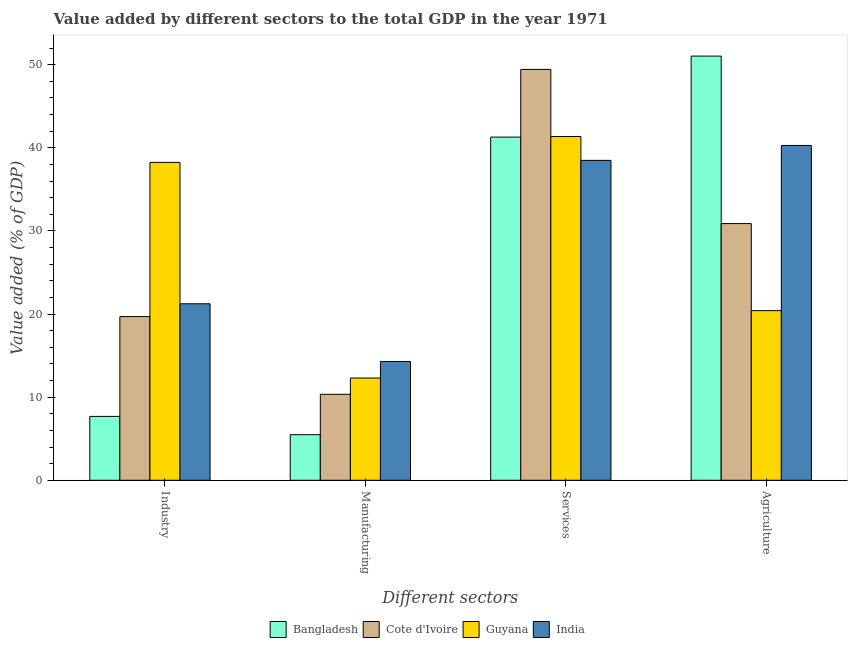How many different coloured bars are there?
Your answer should be very brief. 4. How many groups of bars are there?
Offer a very short reply. 4. Are the number of bars per tick equal to the number of legend labels?
Offer a very short reply. Yes. Are the number of bars on each tick of the X-axis equal?
Your answer should be compact. Yes. How many bars are there on the 1st tick from the left?
Make the answer very short. 4. What is the label of the 3rd group of bars from the left?
Your answer should be compact. Services. What is the value added by agricultural sector in Guyana?
Offer a very short reply. 20.41. Across all countries, what is the maximum value added by agricultural sector?
Ensure brevity in your answer.  51.03. Across all countries, what is the minimum value added by industrial sector?
Your answer should be very brief. 7.68. In which country was the value added by industrial sector minimum?
Your answer should be compact. Bangladesh. What is the total value added by services sector in the graph?
Provide a succinct answer. 170.55. What is the difference between the value added by manufacturing sector in Cote d'Ivoire and that in Guyana?
Offer a very short reply. -1.96. What is the difference between the value added by services sector in Cote d'Ivoire and the value added by agricultural sector in Bangladesh?
Provide a short and direct response. -1.6. What is the average value added by agricultural sector per country?
Give a very brief answer. 35.65. What is the difference between the value added by services sector and value added by industrial sector in Guyana?
Your answer should be compact. 3.11. In how many countries, is the value added by manufacturing sector greater than 36 %?
Keep it short and to the point. 0. What is the ratio of the value added by manufacturing sector in Cote d'Ivoire to that in Bangladesh?
Ensure brevity in your answer.  1.88. Is the value added by agricultural sector in Guyana less than that in India?
Your answer should be compact. Yes. Is the difference between the value added by manufacturing sector in Bangladesh and Cote d'Ivoire greater than the difference between the value added by agricultural sector in Bangladesh and Cote d'Ivoire?
Give a very brief answer. No. What is the difference between the highest and the second highest value added by agricultural sector?
Offer a very short reply. 10.75. What is the difference between the highest and the lowest value added by industrial sector?
Your response must be concise. 30.56. Is the sum of the value added by services sector in Cote d'Ivoire and Guyana greater than the maximum value added by agricultural sector across all countries?
Give a very brief answer. Yes. Is it the case that in every country, the sum of the value added by services sector and value added by manufacturing sector is greater than the sum of value added by agricultural sector and value added by industrial sector?
Keep it short and to the point. No. What does the 3rd bar from the left in Manufacturing represents?
Provide a short and direct response. Guyana. What does the 2nd bar from the right in Services represents?
Ensure brevity in your answer.  Guyana. Are all the bars in the graph horizontal?
Your response must be concise. No. How many countries are there in the graph?
Your answer should be very brief. 4. What is the difference between two consecutive major ticks on the Y-axis?
Your answer should be very brief. 10. Does the graph contain grids?
Your answer should be very brief. No. Where does the legend appear in the graph?
Offer a terse response. Bottom center. How are the legend labels stacked?
Ensure brevity in your answer.  Horizontal. What is the title of the graph?
Your answer should be very brief. Value added by different sectors to the total GDP in the year 1971. What is the label or title of the X-axis?
Your response must be concise. Different sectors. What is the label or title of the Y-axis?
Your response must be concise. Value added (% of GDP). What is the Value added (% of GDP) of Bangladesh in Industry?
Your answer should be compact. 7.68. What is the Value added (% of GDP) in Cote d'Ivoire in Industry?
Your answer should be compact. 19.69. What is the Value added (% of GDP) in Guyana in Industry?
Offer a very short reply. 38.24. What is the Value added (% of GDP) in India in Industry?
Provide a short and direct response. 21.23. What is the Value added (% of GDP) in Bangladesh in Manufacturing?
Your answer should be compact. 5.49. What is the Value added (% of GDP) of Cote d'Ivoire in Manufacturing?
Make the answer very short. 10.34. What is the Value added (% of GDP) of Guyana in Manufacturing?
Offer a terse response. 12.3. What is the Value added (% of GDP) of India in Manufacturing?
Your response must be concise. 14.29. What is the Value added (% of GDP) in Bangladesh in Services?
Your response must be concise. 41.28. What is the Value added (% of GDP) of Cote d'Ivoire in Services?
Provide a succinct answer. 49.43. What is the Value added (% of GDP) in Guyana in Services?
Make the answer very short. 41.35. What is the Value added (% of GDP) in India in Services?
Ensure brevity in your answer.  38.49. What is the Value added (% of GDP) of Bangladesh in Agriculture?
Offer a terse response. 51.03. What is the Value added (% of GDP) in Cote d'Ivoire in Agriculture?
Provide a succinct answer. 30.88. What is the Value added (% of GDP) of Guyana in Agriculture?
Provide a short and direct response. 20.41. What is the Value added (% of GDP) of India in Agriculture?
Ensure brevity in your answer.  40.28. Across all Different sectors, what is the maximum Value added (% of GDP) of Bangladesh?
Provide a succinct answer. 51.03. Across all Different sectors, what is the maximum Value added (% of GDP) in Cote d'Ivoire?
Keep it short and to the point. 49.43. Across all Different sectors, what is the maximum Value added (% of GDP) in Guyana?
Your answer should be compact. 41.35. Across all Different sectors, what is the maximum Value added (% of GDP) in India?
Make the answer very short. 40.28. Across all Different sectors, what is the minimum Value added (% of GDP) in Bangladesh?
Keep it short and to the point. 5.49. Across all Different sectors, what is the minimum Value added (% of GDP) of Cote d'Ivoire?
Give a very brief answer. 10.34. Across all Different sectors, what is the minimum Value added (% of GDP) of Guyana?
Offer a terse response. 12.3. Across all Different sectors, what is the minimum Value added (% of GDP) of India?
Your answer should be compact. 14.29. What is the total Value added (% of GDP) in Bangladesh in the graph?
Your response must be concise. 105.49. What is the total Value added (% of GDP) of Cote d'Ivoire in the graph?
Make the answer very short. 110.34. What is the total Value added (% of GDP) of Guyana in the graph?
Ensure brevity in your answer.  112.3. What is the total Value added (% of GDP) in India in the graph?
Your answer should be compact. 114.29. What is the difference between the Value added (% of GDP) in Bangladesh in Industry and that in Manufacturing?
Your answer should be compact. 2.2. What is the difference between the Value added (% of GDP) in Cote d'Ivoire in Industry and that in Manufacturing?
Offer a very short reply. 9.35. What is the difference between the Value added (% of GDP) of Guyana in Industry and that in Manufacturing?
Provide a succinct answer. 25.94. What is the difference between the Value added (% of GDP) of India in Industry and that in Manufacturing?
Keep it short and to the point. 6.94. What is the difference between the Value added (% of GDP) in Bangladesh in Industry and that in Services?
Provide a succinct answer. -33.6. What is the difference between the Value added (% of GDP) of Cote d'Ivoire in Industry and that in Services?
Your answer should be compact. -29.73. What is the difference between the Value added (% of GDP) in Guyana in Industry and that in Services?
Offer a very short reply. -3.11. What is the difference between the Value added (% of GDP) of India in Industry and that in Services?
Provide a succinct answer. -17.25. What is the difference between the Value added (% of GDP) in Bangladesh in Industry and that in Agriculture?
Offer a terse response. -43.35. What is the difference between the Value added (% of GDP) in Cote d'Ivoire in Industry and that in Agriculture?
Keep it short and to the point. -11.19. What is the difference between the Value added (% of GDP) of Guyana in Industry and that in Agriculture?
Provide a succinct answer. 17.84. What is the difference between the Value added (% of GDP) in India in Industry and that in Agriculture?
Your answer should be very brief. -19.05. What is the difference between the Value added (% of GDP) in Bangladesh in Manufacturing and that in Services?
Provide a succinct answer. -35.8. What is the difference between the Value added (% of GDP) of Cote d'Ivoire in Manufacturing and that in Services?
Offer a terse response. -39.09. What is the difference between the Value added (% of GDP) of Guyana in Manufacturing and that in Services?
Offer a very short reply. -29.05. What is the difference between the Value added (% of GDP) in India in Manufacturing and that in Services?
Your answer should be compact. -24.19. What is the difference between the Value added (% of GDP) of Bangladesh in Manufacturing and that in Agriculture?
Provide a short and direct response. -45.55. What is the difference between the Value added (% of GDP) of Cote d'Ivoire in Manufacturing and that in Agriculture?
Your response must be concise. -20.54. What is the difference between the Value added (% of GDP) in Guyana in Manufacturing and that in Agriculture?
Offer a very short reply. -8.11. What is the difference between the Value added (% of GDP) of India in Manufacturing and that in Agriculture?
Ensure brevity in your answer.  -25.99. What is the difference between the Value added (% of GDP) in Bangladesh in Services and that in Agriculture?
Provide a succinct answer. -9.75. What is the difference between the Value added (% of GDP) of Cote d'Ivoire in Services and that in Agriculture?
Ensure brevity in your answer.  18.55. What is the difference between the Value added (% of GDP) in Guyana in Services and that in Agriculture?
Offer a terse response. 20.95. What is the difference between the Value added (% of GDP) in India in Services and that in Agriculture?
Your response must be concise. -1.8. What is the difference between the Value added (% of GDP) in Bangladesh in Industry and the Value added (% of GDP) in Cote d'Ivoire in Manufacturing?
Your answer should be very brief. -2.66. What is the difference between the Value added (% of GDP) of Bangladesh in Industry and the Value added (% of GDP) of Guyana in Manufacturing?
Provide a succinct answer. -4.62. What is the difference between the Value added (% of GDP) in Bangladesh in Industry and the Value added (% of GDP) in India in Manufacturing?
Keep it short and to the point. -6.61. What is the difference between the Value added (% of GDP) of Cote d'Ivoire in Industry and the Value added (% of GDP) of Guyana in Manufacturing?
Provide a succinct answer. 7.39. What is the difference between the Value added (% of GDP) of Cote d'Ivoire in Industry and the Value added (% of GDP) of India in Manufacturing?
Your answer should be compact. 5.4. What is the difference between the Value added (% of GDP) of Guyana in Industry and the Value added (% of GDP) of India in Manufacturing?
Offer a terse response. 23.95. What is the difference between the Value added (% of GDP) in Bangladesh in Industry and the Value added (% of GDP) in Cote d'Ivoire in Services?
Provide a succinct answer. -41.74. What is the difference between the Value added (% of GDP) in Bangladesh in Industry and the Value added (% of GDP) in Guyana in Services?
Your answer should be compact. -33.67. What is the difference between the Value added (% of GDP) of Bangladesh in Industry and the Value added (% of GDP) of India in Services?
Give a very brief answer. -30.8. What is the difference between the Value added (% of GDP) of Cote d'Ivoire in Industry and the Value added (% of GDP) of Guyana in Services?
Keep it short and to the point. -21.66. What is the difference between the Value added (% of GDP) in Cote d'Ivoire in Industry and the Value added (% of GDP) in India in Services?
Ensure brevity in your answer.  -18.79. What is the difference between the Value added (% of GDP) of Guyana in Industry and the Value added (% of GDP) of India in Services?
Offer a very short reply. -0.24. What is the difference between the Value added (% of GDP) in Bangladesh in Industry and the Value added (% of GDP) in Cote d'Ivoire in Agriculture?
Keep it short and to the point. -23.2. What is the difference between the Value added (% of GDP) in Bangladesh in Industry and the Value added (% of GDP) in Guyana in Agriculture?
Offer a very short reply. -12.72. What is the difference between the Value added (% of GDP) of Bangladesh in Industry and the Value added (% of GDP) of India in Agriculture?
Make the answer very short. -32.6. What is the difference between the Value added (% of GDP) in Cote d'Ivoire in Industry and the Value added (% of GDP) in Guyana in Agriculture?
Your answer should be very brief. -0.71. What is the difference between the Value added (% of GDP) of Cote d'Ivoire in Industry and the Value added (% of GDP) of India in Agriculture?
Your answer should be compact. -20.59. What is the difference between the Value added (% of GDP) in Guyana in Industry and the Value added (% of GDP) in India in Agriculture?
Give a very brief answer. -2.04. What is the difference between the Value added (% of GDP) of Bangladesh in Manufacturing and the Value added (% of GDP) of Cote d'Ivoire in Services?
Ensure brevity in your answer.  -43.94. What is the difference between the Value added (% of GDP) in Bangladesh in Manufacturing and the Value added (% of GDP) in Guyana in Services?
Offer a terse response. -35.87. What is the difference between the Value added (% of GDP) of Bangladesh in Manufacturing and the Value added (% of GDP) of India in Services?
Your answer should be very brief. -33. What is the difference between the Value added (% of GDP) of Cote d'Ivoire in Manufacturing and the Value added (% of GDP) of Guyana in Services?
Provide a short and direct response. -31.01. What is the difference between the Value added (% of GDP) in Cote d'Ivoire in Manufacturing and the Value added (% of GDP) in India in Services?
Give a very brief answer. -28.15. What is the difference between the Value added (% of GDP) of Guyana in Manufacturing and the Value added (% of GDP) of India in Services?
Your answer should be very brief. -26.19. What is the difference between the Value added (% of GDP) in Bangladesh in Manufacturing and the Value added (% of GDP) in Cote d'Ivoire in Agriculture?
Make the answer very short. -25.4. What is the difference between the Value added (% of GDP) of Bangladesh in Manufacturing and the Value added (% of GDP) of Guyana in Agriculture?
Your response must be concise. -14.92. What is the difference between the Value added (% of GDP) of Bangladesh in Manufacturing and the Value added (% of GDP) of India in Agriculture?
Offer a terse response. -34.8. What is the difference between the Value added (% of GDP) in Cote d'Ivoire in Manufacturing and the Value added (% of GDP) in Guyana in Agriculture?
Make the answer very short. -10.07. What is the difference between the Value added (% of GDP) of Cote d'Ivoire in Manufacturing and the Value added (% of GDP) of India in Agriculture?
Give a very brief answer. -29.94. What is the difference between the Value added (% of GDP) in Guyana in Manufacturing and the Value added (% of GDP) in India in Agriculture?
Provide a succinct answer. -27.98. What is the difference between the Value added (% of GDP) of Bangladesh in Services and the Value added (% of GDP) of Cote d'Ivoire in Agriculture?
Your answer should be very brief. 10.4. What is the difference between the Value added (% of GDP) in Bangladesh in Services and the Value added (% of GDP) in Guyana in Agriculture?
Give a very brief answer. 20.88. What is the difference between the Value added (% of GDP) in Bangladesh in Services and the Value added (% of GDP) in India in Agriculture?
Your response must be concise. 1. What is the difference between the Value added (% of GDP) of Cote d'Ivoire in Services and the Value added (% of GDP) of Guyana in Agriculture?
Your answer should be very brief. 29.02. What is the difference between the Value added (% of GDP) of Cote d'Ivoire in Services and the Value added (% of GDP) of India in Agriculture?
Give a very brief answer. 9.15. What is the difference between the Value added (% of GDP) of Guyana in Services and the Value added (% of GDP) of India in Agriculture?
Give a very brief answer. 1.07. What is the average Value added (% of GDP) in Bangladesh per Different sectors?
Your answer should be very brief. 26.37. What is the average Value added (% of GDP) of Cote d'Ivoire per Different sectors?
Provide a short and direct response. 27.58. What is the average Value added (% of GDP) of Guyana per Different sectors?
Give a very brief answer. 28.07. What is the average Value added (% of GDP) of India per Different sectors?
Offer a terse response. 28.57. What is the difference between the Value added (% of GDP) of Bangladesh and Value added (% of GDP) of Cote d'Ivoire in Industry?
Your answer should be very brief. -12.01. What is the difference between the Value added (% of GDP) in Bangladesh and Value added (% of GDP) in Guyana in Industry?
Your answer should be compact. -30.56. What is the difference between the Value added (% of GDP) of Bangladesh and Value added (% of GDP) of India in Industry?
Your answer should be very brief. -13.55. What is the difference between the Value added (% of GDP) in Cote d'Ivoire and Value added (% of GDP) in Guyana in Industry?
Your response must be concise. -18.55. What is the difference between the Value added (% of GDP) in Cote d'Ivoire and Value added (% of GDP) in India in Industry?
Your answer should be very brief. -1.54. What is the difference between the Value added (% of GDP) in Guyana and Value added (% of GDP) in India in Industry?
Your response must be concise. 17.01. What is the difference between the Value added (% of GDP) of Bangladesh and Value added (% of GDP) of Cote d'Ivoire in Manufacturing?
Ensure brevity in your answer.  -4.85. What is the difference between the Value added (% of GDP) in Bangladesh and Value added (% of GDP) in Guyana in Manufacturing?
Offer a terse response. -6.81. What is the difference between the Value added (% of GDP) of Bangladesh and Value added (% of GDP) of India in Manufacturing?
Provide a short and direct response. -8.81. What is the difference between the Value added (% of GDP) in Cote d'Ivoire and Value added (% of GDP) in Guyana in Manufacturing?
Offer a terse response. -1.96. What is the difference between the Value added (% of GDP) of Cote d'Ivoire and Value added (% of GDP) of India in Manufacturing?
Your response must be concise. -3.95. What is the difference between the Value added (% of GDP) in Guyana and Value added (% of GDP) in India in Manufacturing?
Your answer should be very brief. -1.99. What is the difference between the Value added (% of GDP) in Bangladesh and Value added (% of GDP) in Cote d'Ivoire in Services?
Make the answer very short. -8.14. What is the difference between the Value added (% of GDP) in Bangladesh and Value added (% of GDP) in Guyana in Services?
Provide a short and direct response. -0.07. What is the difference between the Value added (% of GDP) of Bangladesh and Value added (% of GDP) of India in Services?
Give a very brief answer. 2.8. What is the difference between the Value added (% of GDP) in Cote d'Ivoire and Value added (% of GDP) in Guyana in Services?
Offer a very short reply. 8.07. What is the difference between the Value added (% of GDP) in Cote d'Ivoire and Value added (% of GDP) in India in Services?
Make the answer very short. 10.94. What is the difference between the Value added (% of GDP) of Guyana and Value added (% of GDP) of India in Services?
Your response must be concise. 2.87. What is the difference between the Value added (% of GDP) of Bangladesh and Value added (% of GDP) of Cote d'Ivoire in Agriculture?
Keep it short and to the point. 20.15. What is the difference between the Value added (% of GDP) of Bangladesh and Value added (% of GDP) of Guyana in Agriculture?
Make the answer very short. 30.63. What is the difference between the Value added (% of GDP) in Bangladesh and Value added (% of GDP) in India in Agriculture?
Give a very brief answer. 10.75. What is the difference between the Value added (% of GDP) in Cote d'Ivoire and Value added (% of GDP) in Guyana in Agriculture?
Your response must be concise. 10.47. What is the difference between the Value added (% of GDP) of Cote d'Ivoire and Value added (% of GDP) of India in Agriculture?
Ensure brevity in your answer.  -9.4. What is the difference between the Value added (% of GDP) of Guyana and Value added (% of GDP) of India in Agriculture?
Ensure brevity in your answer.  -19.88. What is the ratio of the Value added (% of GDP) in Bangladesh in Industry to that in Manufacturing?
Keep it short and to the point. 1.4. What is the ratio of the Value added (% of GDP) of Cote d'Ivoire in Industry to that in Manufacturing?
Keep it short and to the point. 1.9. What is the ratio of the Value added (% of GDP) in Guyana in Industry to that in Manufacturing?
Ensure brevity in your answer.  3.11. What is the ratio of the Value added (% of GDP) in India in Industry to that in Manufacturing?
Your answer should be very brief. 1.49. What is the ratio of the Value added (% of GDP) in Bangladesh in Industry to that in Services?
Your response must be concise. 0.19. What is the ratio of the Value added (% of GDP) in Cote d'Ivoire in Industry to that in Services?
Offer a terse response. 0.4. What is the ratio of the Value added (% of GDP) of Guyana in Industry to that in Services?
Your answer should be compact. 0.92. What is the ratio of the Value added (% of GDP) in India in Industry to that in Services?
Make the answer very short. 0.55. What is the ratio of the Value added (% of GDP) in Bangladesh in Industry to that in Agriculture?
Provide a succinct answer. 0.15. What is the ratio of the Value added (% of GDP) in Cote d'Ivoire in Industry to that in Agriculture?
Keep it short and to the point. 0.64. What is the ratio of the Value added (% of GDP) of Guyana in Industry to that in Agriculture?
Your response must be concise. 1.87. What is the ratio of the Value added (% of GDP) of India in Industry to that in Agriculture?
Offer a very short reply. 0.53. What is the ratio of the Value added (% of GDP) of Bangladesh in Manufacturing to that in Services?
Give a very brief answer. 0.13. What is the ratio of the Value added (% of GDP) in Cote d'Ivoire in Manufacturing to that in Services?
Provide a succinct answer. 0.21. What is the ratio of the Value added (% of GDP) of Guyana in Manufacturing to that in Services?
Your answer should be very brief. 0.3. What is the ratio of the Value added (% of GDP) of India in Manufacturing to that in Services?
Ensure brevity in your answer.  0.37. What is the ratio of the Value added (% of GDP) of Bangladesh in Manufacturing to that in Agriculture?
Ensure brevity in your answer.  0.11. What is the ratio of the Value added (% of GDP) of Cote d'Ivoire in Manufacturing to that in Agriculture?
Keep it short and to the point. 0.33. What is the ratio of the Value added (% of GDP) in Guyana in Manufacturing to that in Agriculture?
Keep it short and to the point. 0.6. What is the ratio of the Value added (% of GDP) in India in Manufacturing to that in Agriculture?
Your answer should be compact. 0.35. What is the ratio of the Value added (% of GDP) in Bangladesh in Services to that in Agriculture?
Your answer should be very brief. 0.81. What is the ratio of the Value added (% of GDP) of Cote d'Ivoire in Services to that in Agriculture?
Keep it short and to the point. 1.6. What is the ratio of the Value added (% of GDP) of Guyana in Services to that in Agriculture?
Your response must be concise. 2.03. What is the ratio of the Value added (% of GDP) in India in Services to that in Agriculture?
Your answer should be compact. 0.96. What is the difference between the highest and the second highest Value added (% of GDP) of Bangladesh?
Offer a very short reply. 9.75. What is the difference between the highest and the second highest Value added (% of GDP) in Cote d'Ivoire?
Your response must be concise. 18.55. What is the difference between the highest and the second highest Value added (% of GDP) of Guyana?
Keep it short and to the point. 3.11. What is the difference between the highest and the second highest Value added (% of GDP) in India?
Your response must be concise. 1.8. What is the difference between the highest and the lowest Value added (% of GDP) of Bangladesh?
Your response must be concise. 45.55. What is the difference between the highest and the lowest Value added (% of GDP) of Cote d'Ivoire?
Offer a terse response. 39.09. What is the difference between the highest and the lowest Value added (% of GDP) in Guyana?
Your answer should be compact. 29.05. What is the difference between the highest and the lowest Value added (% of GDP) of India?
Give a very brief answer. 25.99. 